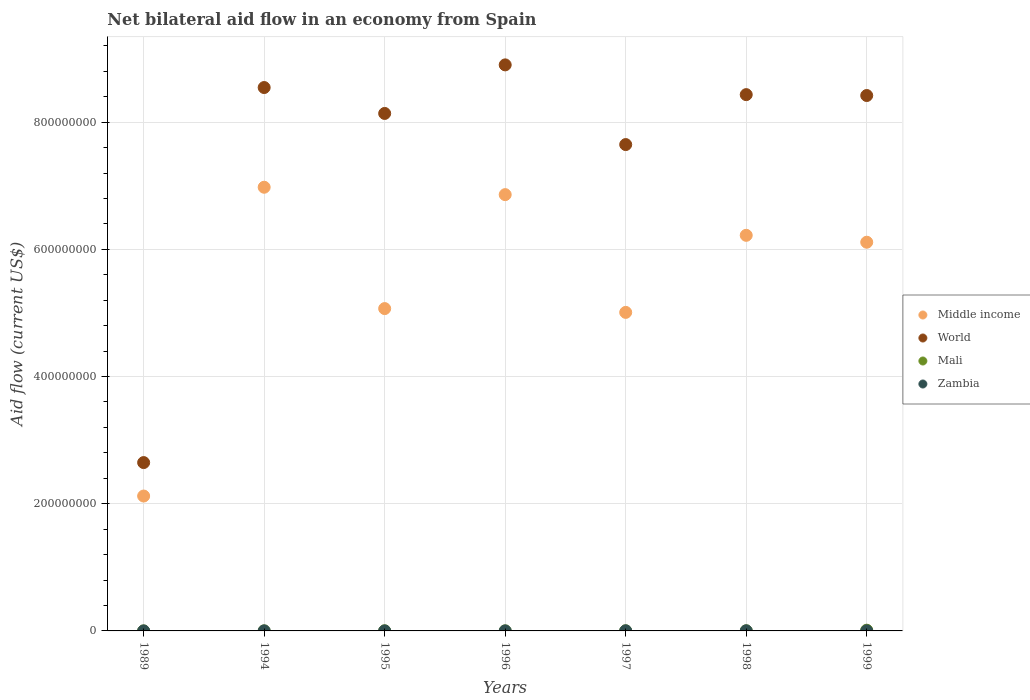How many different coloured dotlines are there?
Provide a short and direct response. 4. Is the number of dotlines equal to the number of legend labels?
Keep it short and to the point. Yes. Across all years, what is the minimum net bilateral aid flow in Zambia?
Give a very brief answer. 10000. What is the total net bilateral aid flow in World in the graph?
Your answer should be very brief. 5.27e+09. What is the difference between the net bilateral aid flow in Zambia in 1998 and that in 1999?
Make the answer very short. 10000. What is the difference between the net bilateral aid flow in Middle income in 1998 and the net bilateral aid flow in World in 1999?
Provide a succinct answer. -2.20e+08. What is the average net bilateral aid flow in Middle income per year?
Ensure brevity in your answer.  5.48e+08. In the year 1999, what is the difference between the net bilateral aid flow in Mali and net bilateral aid flow in Zambia?
Give a very brief answer. 9.90e+05. What is the ratio of the net bilateral aid flow in Middle income in 1997 to that in 1998?
Your answer should be compact. 0.81. Is the net bilateral aid flow in Mali in 1994 less than that in 1997?
Offer a very short reply. Yes. What is the difference between the highest and the second highest net bilateral aid flow in Mali?
Keep it short and to the point. 9.30e+05. What is the difference between the highest and the lowest net bilateral aid flow in Middle income?
Give a very brief answer. 4.86e+08. Does the net bilateral aid flow in World monotonically increase over the years?
Your response must be concise. No. Is the net bilateral aid flow in Middle income strictly less than the net bilateral aid flow in Zambia over the years?
Make the answer very short. No. How many dotlines are there?
Offer a very short reply. 4. Does the graph contain any zero values?
Keep it short and to the point. No. Where does the legend appear in the graph?
Make the answer very short. Center right. How many legend labels are there?
Ensure brevity in your answer.  4. How are the legend labels stacked?
Your answer should be very brief. Vertical. What is the title of the graph?
Provide a succinct answer. Net bilateral aid flow in an economy from Spain. Does "Yemen, Rep." appear as one of the legend labels in the graph?
Ensure brevity in your answer.  No. What is the label or title of the X-axis?
Your answer should be very brief. Years. What is the Aid flow (current US$) of Middle income in 1989?
Offer a very short reply. 2.12e+08. What is the Aid flow (current US$) in World in 1989?
Give a very brief answer. 2.65e+08. What is the Aid flow (current US$) in Zambia in 1989?
Make the answer very short. 10000. What is the Aid flow (current US$) of Middle income in 1994?
Ensure brevity in your answer.  6.98e+08. What is the Aid flow (current US$) in World in 1994?
Provide a short and direct response. 8.54e+08. What is the Aid flow (current US$) of Mali in 1994?
Keep it short and to the point. 8.00e+04. What is the Aid flow (current US$) in Middle income in 1995?
Your answer should be very brief. 5.07e+08. What is the Aid flow (current US$) in World in 1995?
Offer a terse response. 8.14e+08. What is the Aid flow (current US$) in Mali in 1995?
Keep it short and to the point. 1.90e+05. What is the Aid flow (current US$) in Zambia in 1995?
Provide a short and direct response. 2.00e+04. What is the Aid flow (current US$) of Middle income in 1996?
Your answer should be compact. 6.86e+08. What is the Aid flow (current US$) of World in 1996?
Keep it short and to the point. 8.90e+08. What is the Aid flow (current US$) in Zambia in 1996?
Provide a succinct answer. 2.00e+04. What is the Aid flow (current US$) of Middle income in 1997?
Offer a very short reply. 5.01e+08. What is the Aid flow (current US$) in World in 1997?
Offer a terse response. 7.65e+08. What is the Aid flow (current US$) of Mali in 1997?
Offer a very short reply. 1.80e+05. What is the Aid flow (current US$) in Middle income in 1998?
Give a very brief answer. 6.22e+08. What is the Aid flow (current US$) of World in 1998?
Offer a terse response. 8.43e+08. What is the Aid flow (current US$) in Mali in 1998?
Give a very brief answer. 2.10e+05. What is the Aid flow (current US$) in Zambia in 1998?
Keep it short and to the point. 1.60e+05. What is the Aid flow (current US$) of Middle income in 1999?
Your response must be concise. 6.11e+08. What is the Aid flow (current US$) of World in 1999?
Offer a very short reply. 8.42e+08. What is the Aid flow (current US$) in Mali in 1999?
Provide a short and direct response. 1.14e+06. Across all years, what is the maximum Aid flow (current US$) of Middle income?
Your answer should be compact. 6.98e+08. Across all years, what is the maximum Aid flow (current US$) of World?
Provide a succinct answer. 8.90e+08. Across all years, what is the maximum Aid flow (current US$) of Mali?
Your response must be concise. 1.14e+06. Across all years, what is the maximum Aid flow (current US$) of Zambia?
Ensure brevity in your answer.  1.70e+05. Across all years, what is the minimum Aid flow (current US$) of Middle income?
Your answer should be very brief. 2.12e+08. Across all years, what is the minimum Aid flow (current US$) of World?
Offer a terse response. 2.65e+08. Across all years, what is the minimum Aid flow (current US$) in Mali?
Your response must be concise. 10000. What is the total Aid flow (current US$) of Middle income in the graph?
Offer a terse response. 3.84e+09. What is the total Aid flow (current US$) of World in the graph?
Offer a terse response. 5.27e+09. What is the total Aid flow (current US$) of Mali in the graph?
Your answer should be compact. 1.91e+06. What is the total Aid flow (current US$) in Zambia in the graph?
Make the answer very short. 5.90e+05. What is the difference between the Aid flow (current US$) of Middle income in 1989 and that in 1994?
Your answer should be very brief. -4.86e+08. What is the difference between the Aid flow (current US$) of World in 1989 and that in 1994?
Provide a succinct answer. -5.90e+08. What is the difference between the Aid flow (current US$) of Zambia in 1989 and that in 1994?
Ensure brevity in your answer.  -5.00e+04. What is the difference between the Aid flow (current US$) in Middle income in 1989 and that in 1995?
Offer a terse response. -2.95e+08. What is the difference between the Aid flow (current US$) in World in 1989 and that in 1995?
Your answer should be very brief. -5.49e+08. What is the difference between the Aid flow (current US$) in Mali in 1989 and that in 1995?
Your answer should be very brief. -1.80e+05. What is the difference between the Aid flow (current US$) of Middle income in 1989 and that in 1996?
Your answer should be very brief. -4.74e+08. What is the difference between the Aid flow (current US$) in World in 1989 and that in 1996?
Your answer should be compact. -6.25e+08. What is the difference between the Aid flow (current US$) of Mali in 1989 and that in 1996?
Ensure brevity in your answer.  -9.00e+04. What is the difference between the Aid flow (current US$) in Zambia in 1989 and that in 1996?
Provide a succinct answer. -10000. What is the difference between the Aid flow (current US$) in Middle income in 1989 and that in 1997?
Keep it short and to the point. -2.89e+08. What is the difference between the Aid flow (current US$) of World in 1989 and that in 1997?
Offer a very short reply. -5.00e+08. What is the difference between the Aid flow (current US$) in Mali in 1989 and that in 1997?
Your answer should be very brief. -1.70e+05. What is the difference between the Aid flow (current US$) of Middle income in 1989 and that in 1998?
Your answer should be compact. -4.10e+08. What is the difference between the Aid flow (current US$) in World in 1989 and that in 1998?
Give a very brief answer. -5.79e+08. What is the difference between the Aid flow (current US$) of Mali in 1989 and that in 1998?
Provide a short and direct response. -2.00e+05. What is the difference between the Aid flow (current US$) in Zambia in 1989 and that in 1998?
Your response must be concise. -1.50e+05. What is the difference between the Aid flow (current US$) of Middle income in 1989 and that in 1999?
Keep it short and to the point. -3.99e+08. What is the difference between the Aid flow (current US$) in World in 1989 and that in 1999?
Provide a short and direct response. -5.77e+08. What is the difference between the Aid flow (current US$) of Mali in 1989 and that in 1999?
Ensure brevity in your answer.  -1.13e+06. What is the difference between the Aid flow (current US$) of Middle income in 1994 and that in 1995?
Your answer should be very brief. 1.91e+08. What is the difference between the Aid flow (current US$) in World in 1994 and that in 1995?
Ensure brevity in your answer.  4.07e+07. What is the difference between the Aid flow (current US$) in Mali in 1994 and that in 1995?
Your answer should be compact. -1.10e+05. What is the difference between the Aid flow (current US$) in Zambia in 1994 and that in 1995?
Give a very brief answer. 4.00e+04. What is the difference between the Aid flow (current US$) of Middle income in 1994 and that in 1996?
Your response must be concise. 1.16e+07. What is the difference between the Aid flow (current US$) in World in 1994 and that in 1996?
Your answer should be compact. -3.56e+07. What is the difference between the Aid flow (current US$) in Mali in 1994 and that in 1996?
Make the answer very short. -2.00e+04. What is the difference between the Aid flow (current US$) in Zambia in 1994 and that in 1996?
Your answer should be compact. 4.00e+04. What is the difference between the Aid flow (current US$) in Middle income in 1994 and that in 1997?
Ensure brevity in your answer.  1.97e+08. What is the difference between the Aid flow (current US$) in World in 1994 and that in 1997?
Offer a very short reply. 8.97e+07. What is the difference between the Aid flow (current US$) in Middle income in 1994 and that in 1998?
Provide a short and direct response. 7.56e+07. What is the difference between the Aid flow (current US$) of World in 1994 and that in 1998?
Keep it short and to the point. 1.12e+07. What is the difference between the Aid flow (current US$) in Zambia in 1994 and that in 1998?
Provide a succinct answer. -1.00e+05. What is the difference between the Aid flow (current US$) in Middle income in 1994 and that in 1999?
Make the answer very short. 8.65e+07. What is the difference between the Aid flow (current US$) in World in 1994 and that in 1999?
Make the answer very short. 1.26e+07. What is the difference between the Aid flow (current US$) in Mali in 1994 and that in 1999?
Provide a short and direct response. -1.06e+06. What is the difference between the Aid flow (current US$) of Zambia in 1994 and that in 1999?
Offer a terse response. -9.00e+04. What is the difference between the Aid flow (current US$) of Middle income in 1995 and that in 1996?
Keep it short and to the point. -1.79e+08. What is the difference between the Aid flow (current US$) in World in 1995 and that in 1996?
Your answer should be compact. -7.64e+07. What is the difference between the Aid flow (current US$) in Mali in 1995 and that in 1996?
Your answer should be very brief. 9.00e+04. What is the difference between the Aid flow (current US$) of Zambia in 1995 and that in 1996?
Ensure brevity in your answer.  0. What is the difference between the Aid flow (current US$) in Middle income in 1995 and that in 1997?
Ensure brevity in your answer.  5.98e+06. What is the difference between the Aid flow (current US$) in World in 1995 and that in 1997?
Your answer should be compact. 4.89e+07. What is the difference between the Aid flow (current US$) in Mali in 1995 and that in 1997?
Your answer should be compact. 10000. What is the difference between the Aid flow (current US$) of Zambia in 1995 and that in 1997?
Offer a terse response. -1.50e+05. What is the difference between the Aid flow (current US$) of Middle income in 1995 and that in 1998?
Your response must be concise. -1.15e+08. What is the difference between the Aid flow (current US$) of World in 1995 and that in 1998?
Provide a short and direct response. -2.96e+07. What is the difference between the Aid flow (current US$) in Mali in 1995 and that in 1998?
Offer a terse response. -2.00e+04. What is the difference between the Aid flow (current US$) in Middle income in 1995 and that in 1999?
Offer a terse response. -1.04e+08. What is the difference between the Aid flow (current US$) of World in 1995 and that in 1999?
Offer a very short reply. -2.82e+07. What is the difference between the Aid flow (current US$) in Mali in 1995 and that in 1999?
Give a very brief answer. -9.50e+05. What is the difference between the Aid flow (current US$) in Zambia in 1995 and that in 1999?
Provide a succinct answer. -1.30e+05. What is the difference between the Aid flow (current US$) of Middle income in 1996 and that in 1997?
Your answer should be compact. 1.85e+08. What is the difference between the Aid flow (current US$) in World in 1996 and that in 1997?
Make the answer very short. 1.25e+08. What is the difference between the Aid flow (current US$) of Mali in 1996 and that in 1997?
Ensure brevity in your answer.  -8.00e+04. What is the difference between the Aid flow (current US$) in Middle income in 1996 and that in 1998?
Keep it short and to the point. 6.40e+07. What is the difference between the Aid flow (current US$) of World in 1996 and that in 1998?
Your response must be concise. 4.68e+07. What is the difference between the Aid flow (current US$) in Middle income in 1996 and that in 1999?
Provide a short and direct response. 7.48e+07. What is the difference between the Aid flow (current US$) of World in 1996 and that in 1999?
Your answer should be very brief. 4.82e+07. What is the difference between the Aid flow (current US$) in Mali in 1996 and that in 1999?
Ensure brevity in your answer.  -1.04e+06. What is the difference between the Aid flow (current US$) of Middle income in 1997 and that in 1998?
Offer a terse response. -1.21e+08. What is the difference between the Aid flow (current US$) of World in 1997 and that in 1998?
Ensure brevity in your answer.  -7.85e+07. What is the difference between the Aid flow (current US$) of Mali in 1997 and that in 1998?
Offer a terse response. -3.00e+04. What is the difference between the Aid flow (current US$) of Middle income in 1997 and that in 1999?
Provide a succinct answer. -1.10e+08. What is the difference between the Aid flow (current US$) of World in 1997 and that in 1999?
Provide a short and direct response. -7.71e+07. What is the difference between the Aid flow (current US$) of Mali in 1997 and that in 1999?
Give a very brief answer. -9.60e+05. What is the difference between the Aid flow (current US$) of Middle income in 1998 and that in 1999?
Ensure brevity in your answer.  1.09e+07. What is the difference between the Aid flow (current US$) in World in 1998 and that in 1999?
Your answer should be compact. 1.40e+06. What is the difference between the Aid flow (current US$) in Mali in 1998 and that in 1999?
Make the answer very short. -9.30e+05. What is the difference between the Aid flow (current US$) of Middle income in 1989 and the Aid flow (current US$) of World in 1994?
Your response must be concise. -6.42e+08. What is the difference between the Aid flow (current US$) of Middle income in 1989 and the Aid flow (current US$) of Mali in 1994?
Offer a very short reply. 2.12e+08. What is the difference between the Aid flow (current US$) of Middle income in 1989 and the Aid flow (current US$) of Zambia in 1994?
Provide a succinct answer. 2.12e+08. What is the difference between the Aid flow (current US$) of World in 1989 and the Aid flow (current US$) of Mali in 1994?
Your answer should be compact. 2.65e+08. What is the difference between the Aid flow (current US$) of World in 1989 and the Aid flow (current US$) of Zambia in 1994?
Provide a short and direct response. 2.65e+08. What is the difference between the Aid flow (current US$) in Middle income in 1989 and the Aid flow (current US$) in World in 1995?
Offer a very short reply. -6.02e+08. What is the difference between the Aid flow (current US$) in Middle income in 1989 and the Aid flow (current US$) in Mali in 1995?
Offer a terse response. 2.12e+08. What is the difference between the Aid flow (current US$) of Middle income in 1989 and the Aid flow (current US$) of Zambia in 1995?
Your answer should be very brief. 2.12e+08. What is the difference between the Aid flow (current US$) in World in 1989 and the Aid flow (current US$) in Mali in 1995?
Provide a succinct answer. 2.64e+08. What is the difference between the Aid flow (current US$) of World in 1989 and the Aid flow (current US$) of Zambia in 1995?
Keep it short and to the point. 2.65e+08. What is the difference between the Aid flow (current US$) in Middle income in 1989 and the Aid flow (current US$) in World in 1996?
Make the answer very short. -6.78e+08. What is the difference between the Aid flow (current US$) in Middle income in 1989 and the Aid flow (current US$) in Mali in 1996?
Make the answer very short. 2.12e+08. What is the difference between the Aid flow (current US$) of Middle income in 1989 and the Aid flow (current US$) of Zambia in 1996?
Your response must be concise. 2.12e+08. What is the difference between the Aid flow (current US$) of World in 1989 and the Aid flow (current US$) of Mali in 1996?
Your response must be concise. 2.65e+08. What is the difference between the Aid flow (current US$) of World in 1989 and the Aid flow (current US$) of Zambia in 1996?
Your answer should be very brief. 2.65e+08. What is the difference between the Aid flow (current US$) of Mali in 1989 and the Aid flow (current US$) of Zambia in 1996?
Keep it short and to the point. -10000. What is the difference between the Aid flow (current US$) of Middle income in 1989 and the Aid flow (current US$) of World in 1997?
Your answer should be very brief. -5.53e+08. What is the difference between the Aid flow (current US$) in Middle income in 1989 and the Aid flow (current US$) in Mali in 1997?
Provide a succinct answer. 2.12e+08. What is the difference between the Aid flow (current US$) in Middle income in 1989 and the Aid flow (current US$) in Zambia in 1997?
Ensure brevity in your answer.  2.12e+08. What is the difference between the Aid flow (current US$) of World in 1989 and the Aid flow (current US$) of Mali in 1997?
Keep it short and to the point. 2.65e+08. What is the difference between the Aid flow (current US$) in World in 1989 and the Aid flow (current US$) in Zambia in 1997?
Provide a succinct answer. 2.65e+08. What is the difference between the Aid flow (current US$) in Middle income in 1989 and the Aid flow (current US$) in World in 1998?
Your response must be concise. -6.31e+08. What is the difference between the Aid flow (current US$) in Middle income in 1989 and the Aid flow (current US$) in Mali in 1998?
Your answer should be compact. 2.12e+08. What is the difference between the Aid flow (current US$) of Middle income in 1989 and the Aid flow (current US$) of Zambia in 1998?
Make the answer very short. 2.12e+08. What is the difference between the Aid flow (current US$) of World in 1989 and the Aid flow (current US$) of Mali in 1998?
Your response must be concise. 2.64e+08. What is the difference between the Aid flow (current US$) of World in 1989 and the Aid flow (current US$) of Zambia in 1998?
Give a very brief answer. 2.65e+08. What is the difference between the Aid flow (current US$) of Mali in 1989 and the Aid flow (current US$) of Zambia in 1998?
Ensure brevity in your answer.  -1.50e+05. What is the difference between the Aid flow (current US$) of Middle income in 1989 and the Aid flow (current US$) of World in 1999?
Offer a very short reply. -6.30e+08. What is the difference between the Aid flow (current US$) in Middle income in 1989 and the Aid flow (current US$) in Mali in 1999?
Your answer should be very brief. 2.11e+08. What is the difference between the Aid flow (current US$) of Middle income in 1989 and the Aid flow (current US$) of Zambia in 1999?
Provide a succinct answer. 2.12e+08. What is the difference between the Aid flow (current US$) in World in 1989 and the Aid flow (current US$) in Mali in 1999?
Provide a short and direct response. 2.64e+08. What is the difference between the Aid flow (current US$) of World in 1989 and the Aid flow (current US$) of Zambia in 1999?
Keep it short and to the point. 2.65e+08. What is the difference between the Aid flow (current US$) of Mali in 1989 and the Aid flow (current US$) of Zambia in 1999?
Provide a short and direct response. -1.40e+05. What is the difference between the Aid flow (current US$) in Middle income in 1994 and the Aid flow (current US$) in World in 1995?
Your response must be concise. -1.16e+08. What is the difference between the Aid flow (current US$) in Middle income in 1994 and the Aid flow (current US$) in Mali in 1995?
Keep it short and to the point. 6.97e+08. What is the difference between the Aid flow (current US$) of Middle income in 1994 and the Aid flow (current US$) of Zambia in 1995?
Keep it short and to the point. 6.98e+08. What is the difference between the Aid flow (current US$) in World in 1994 and the Aid flow (current US$) in Mali in 1995?
Your answer should be very brief. 8.54e+08. What is the difference between the Aid flow (current US$) of World in 1994 and the Aid flow (current US$) of Zambia in 1995?
Make the answer very short. 8.54e+08. What is the difference between the Aid flow (current US$) of Middle income in 1994 and the Aid flow (current US$) of World in 1996?
Give a very brief answer. -1.92e+08. What is the difference between the Aid flow (current US$) in Middle income in 1994 and the Aid flow (current US$) in Mali in 1996?
Make the answer very short. 6.98e+08. What is the difference between the Aid flow (current US$) of Middle income in 1994 and the Aid flow (current US$) of Zambia in 1996?
Offer a terse response. 6.98e+08. What is the difference between the Aid flow (current US$) in World in 1994 and the Aid flow (current US$) in Mali in 1996?
Your answer should be very brief. 8.54e+08. What is the difference between the Aid flow (current US$) in World in 1994 and the Aid flow (current US$) in Zambia in 1996?
Offer a terse response. 8.54e+08. What is the difference between the Aid flow (current US$) of Middle income in 1994 and the Aid flow (current US$) of World in 1997?
Offer a terse response. -6.71e+07. What is the difference between the Aid flow (current US$) in Middle income in 1994 and the Aid flow (current US$) in Mali in 1997?
Give a very brief answer. 6.97e+08. What is the difference between the Aid flow (current US$) in Middle income in 1994 and the Aid flow (current US$) in Zambia in 1997?
Make the answer very short. 6.97e+08. What is the difference between the Aid flow (current US$) in World in 1994 and the Aid flow (current US$) in Mali in 1997?
Keep it short and to the point. 8.54e+08. What is the difference between the Aid flow (current US$) in World in 1994 and the Aid flow (current US$) in Zambia in 1997?
Keep it short and to the point. 8.54e+08. What is the difference between the Aid flow (current US$) in Mali in 1994 and the Aid flow (current US$) in Zambia in 1997?
Give a very brief answer. -9.00e+04. What is the difference between the Aid flow (current US$) in Middle income in 1994 and the Aid flow (current US$) in World in 1998?
Give a very brief answer. -1.46e+08. What is the difference between the Aid flow (current US$) of Middle income in 1994 and the Aid flow (current US$) of Mali in 1998?
Your answer should be compact. 6.97e+08. What is the difference between the Aid flow (current US$) of Middle income in 1994 and the Aid flow (current US$) of Zambia in 1998?
Your answer should be compact. 6.97e+08. What is the difference between the Aid flow (current US$) of World in 1994 and the Aid flow (current US$) of Mali in 1998?
Your answer should be very brief. 8.54e+08. What is the difference between the Aid flow (current US$) of World in 1994 and the Aid flow (current US$) of Zambia in 1998?
Your answer should be compact. 8.54e+08. What is the difference between the Aid flow (current US$) in Middle income in 1994 and the Aid flow (current US$) in World in 1999?
Provide a short and direct response. -1.44e+08. What is the difference between the Aid flow (current US$) of Middle income in 1994 and the Aid flow (current US$) of Mali in 1999?
Keep it short and to the point. 6.96e+08. What is the difference between the Aid flow (current US$) in Middle income in 1994 and the Aid flow (current US$) in Zambia in 1999?
Your response must be concise. 6.97e+08. What is the difference between the Aid flow (current US$) of World in 1994 and the Aid flow (current US$) of Mali in 1999?
Offer a very short reply. 8.53e+08. What is the difference between the Aid flow (current US$) in World in 1994 and the Aid flow (current US$) in Zambia in 1999?
Offer a very short reply. 8.54e+08. What is the difference between the Aid flow (current US$) of Middle income in 1995 and the Aid flow (current US$) of World in 1996?
Make the answer very short. -3.83e+08. What is the difference between the Aid flow (current US$) in Middle income in 1995 and the Aid flow (current US$) in Mali in 1996?
Offer a very short reply. 5.07e+08. What is the difference between the Aid flow (current US$) of Middle income in 1995 and the Aid flow (current US$) of Zambia in 1996?
Your response must be concise. 5.07e+08. What is the difference between the Aid flow (current US$) of World in 1995 and the Aid flow (current US$) of Mali in 1996?
Provide a succinct answer. 8.14e+08. What is the difference between the Aid flow (current US$) in World in 1995 and the Aid flow (current US$) in Zambia in 1996?
Your answer should be compact. 8.14e+08. What is the difference between the Aid flow (current US$) in Middle income in 1995 and the Aid flow (current US$) in World in 1997?
Make the answer very short. -2.58e+08. What is the difference between the Aid flow (current US$) of Middle income in 1995 and the Aid flow (current US$) of Mali in 1997?
Offer a terse response. 5.07e+08. What is the difference between the Aid flow (current US$) in Middle income in 1995 and the Aid flow (current US$) in Zambia in 1997?
Give a very brief answer. 5.07e+08. What is the difference between the Aid flow (current US$) in World in 1995 and the Aid flow (current US$) in Mali in 1997?
Offer a very short reply. 8.13e+08. What is the difference between the Aid flow (current US$) in World in 1995 and the Aid flow (current US$) in Zambia in 1997?
Provide a short and direct response. 8.13e+08. What is the difference between the Aid flow (current US$) of Mali in 1995 and the Aid flow (current US$) of Zambia in 1997?
Your answer should be compact. 2.00e+04. What is the difference between the Aid flow (current US$) in Middle income in 1995 and the Aid flow (current US$) in World in 1998?
Offer a very short reply. -3.36e+08. What is the difference between the Aid flow (current US$) in Middle income in 1995 and the Aid flow (current US$) in Mali in 1998?
Your answer should be compact. 5.07e+08. What is the difference between the Aid flow (current US$) in Middle income in 1995 and the Aid flow (current US$) in Zambia in 1998?
Provide a short and direct response. 5.07e+08. What is the difference between the Aid flow (current US$) in World in 1995 and the Aid flow (current US$) in Mali in 1998?
Provide a succinct answer. 8.13e+08. What is the difference between the Aid flow (current US$) in World in 1995 and the Aid flow (current US$) in Zambia in 1998?
Ensure brevity in your answer.  8.13e+08. What is the difference between the Aid flow (current US$) of Mali in 1995 and the Aid flow (current US$) of Zambia in 1998?
Keep it short and to the point. 3.00e+04. What is the difference between the Aid flow (current US$) in Middle income in 1995 and the Aid flow (current US$) in World in 1999?
Your answer should be compact. -3.35e+08. What is the difference between the Aid flow (current US$) of Middle income in 1995 and the Aid flow (current US$) of Mali in 1999?
Your response must be concise. 5.06e+08. What is the difference between the Aid flow (current US$) of Middle income in 1995 and the Aid flow (current US$) of Zambia in 1999?
Make the answer very short. 5.07e+08. What is the difference between the Aid flow (current US$) of World in 1995 and the Aid flow (current US$) of Mali in 1999?
Keep it short and to the point. 8.12e+08. What is the difference between the Aid flow (current US$) of World in 1995 and the Aid flow (current US$) of Zambia in 1999?
Your answer should be very brief. 8.13e+08. What is the difference between the Aid flow (current US$) in Mali in 1995 and the Aid flow (current US$) in Zambia in 1999?
Your answer should be compact. 4.00e+04. What is the difference between the Aid flow (current US$) of Middle income in 1996 and the Aid flow (current US$) of World in 1997?
Give a very brief answer. -7.87e+07. What is the difference between the Aid flow (current US$) in Middle income in 1996 and the Aid flow (current US$) in Mali in 1997?
Offer a very short reply. 6.86e+08. What is the difference between the Aid flow (current US$) of Middle income in 1996 and the Aid flow (current US$) of Zambia in 1997?
Your answer should be very brief. 6.86e+08. What is the difference between the Aid flow (current US$) of World in 1996 and the Aid flow (current US$) of Mali in 1997?
Make the answer very short. 8.90e+08. What is the difference between the Aid flow (current US$) of World in 1996 and the Aid flow (current US$) of Zambia in 1997?
Provide a short and direct response. 8.90e+08. What is the difference between the Aid flow (current US$) in Mali in 1996 and the Aid flow (current US$) in Zambia in 1997?
Provide a short and direct response. -7.00e+04. What is the difference between the Aid flow (current US$) of Middle income in 1996 and the Aid flow (current US$) of World in 1998?
Offer a terse response. -1.57e+08. What is the difference between the Aid flow (current US$) in Middle income in 1996 and the Aid flow (current US$) in Mali in 1998?
Make the answer very short. 6.86e+08. What is the difference between the Aid flow (current US$) in Middle income in 1996 and the Aid flow (current US$) in Zambia in 1998?
Make the answer very short. 6.86e+08. What is the difference between the Aid flow (current US$) of World in 1996 and the Aid flow (current US$) of Mali in 1998?
Offer a terse response. 8.90e+08. What is the difference between the Aid flow (current US$) of World in 1996 and the Aid flow (current US$) of Zambia in 1998?
Your answer should be compact. 8.90e+08. What is the difference between the Aid flow (current US$) of Middle income in 1996 and the Aid flow (current US$) of World in 1999?
Ensure brevity in your answer.  -1.56e+08. What is the difference between the Aid flow (current US$) of Middle income in 1996 and the Aid flow (current US$) of Mali in 1999?
Ensure brevity in your answer.  6.85e+08. What is the difference between the Aid flow (current US$) in Middle income in 1996 and the Aid flow (current US$) in Zambia in 1999?
Keep it short and to the point. 6.86e+08. What is the difference between the Aid flow (current US$) of World in 1996 and the Aid flow (current US$) of Mali in 1999?
Offer a very short reply. 8.89e+08. What is the difference between the Aid flow (current US$) in World in 1996 and the Aid flow (current US$) in Zambia in 1999?
Provide a short and direct response. 8.90e+08. What is the difference between the Aid flow (current US$) of Mali in 1996 and the Aid flow (current US$) of Zambia in 1999?
Your answer should be very brief. -5.00e+04. What is the difference between the Aid flow (current US$) of Middle income in 1997 and the Aid flow (current US$) of World in 1998?
Offer a very short reply. -3.42e+08. What is the difference between the Aid flow (current US$) of Middle income in 1997 and the Aid flow (current US$) of Mali in 1998?
Provide a succinct answer. 5.01e+08. What is the difference between the Aid flow (current US$) of Middle income in 1997 and the Aid flow (current US$) of Zambia in 1998?
Offer a very short reply. 5.01e+08. What is the difference between the Aid flow (current US$) of World in 1997 and the Aid flow (current US$) of Mali in 1998?
Offer a very short reply. 7.64e+08. What is the difference between the Aid flow (current US$) in World in 1997 and the Aid flow (current US$) in Zambia in 1998?
Provide a succinct answer. 7.65e+08. What is the difference between the Aid flow (current US$) in Middle income in 1997 and the Aid flow (current US$) in World in 1999?
Give a very brief answer. -3.41e+08. What is the difference between the Aid flow (current US$) of Middle income in 1997 and the Aid flow (current US$) of Mali in 1999?
Give a very brief answer. 5.00e+08. What is the difference between the Aid flow (current US$) in Middle income in 1997 and the Aid flow (current US$) in Zambia in 1999?
Provide a succinct answer. 5.01e+08. What is the difference between the Aid flow (current US$) of World in 1997 and the Aid flow (current US$) of Mali in 1999?
Make the answer very short. 7.64e+08. What is the difference between the Aid flow (current US$) in World in 1997 and the Aid flow (current US$) in Zambia in 1999?
Make the answer very short. 7.65e+08. What is the difference between the Aid flow (current US$) of Middle income in 1998 and the Aid flow (current US$) of World in 1999?
Your answer should be compact. -2.20e+08. What is the difference between the Aid flow (current US$) in Middle income in 1998 and the Aid flow (current US$) in Mali in 1999?
Offer a very short reply. 6.21e+08. What is the difference between the Aid flow (current US$) in Middle income in 1998 and the Aid flow (current US$) in Zambia in 1999?
Your answer should be very brief. 6.22e+08. What is the difference between the Aid flow (current US$) in World in 1998 and the Aid flow (current US$) in Mali in 1999?
Provide a succinct answer. 8.42e+08. What is the difference between the Aid flow (current US$) in World in 1998 and the Aid flow (current US$) in Zambia in 1999?
Ensure brevity in your answer.  8.43e+08. What is the average Aid flow (current US$) of Middle income per year?
Offer a very short reply. 5.48e+08. What is the average Aid flow (current US$) in World per year?
Provide a short and direct response. 7.53e+08. What is the average Aid flow (current US$) of Mali per year?
Make the answer very short. 2.73e+05. What is the average Aid flow (current US$) of Zambia per year?
Your response must be concise. 8.43e+04. In the year 1989, what is the difference between the Aid flow (current US$) of Middle income and Aid flow (current US$) of World?
Make the answer very short. -5.26e+07. In the year 1989, what is the difference between the Aid flow (current US$) in Middle income and Aid flow (current US$) in Mali?
Your answer should be compact. 2.12e+08. In the year 1989, what is the difference between the Aid flow (current US$) in Middle income and Aid flow (current US$) in Zambia?
Give a very brief answer. 2.12e+08. In the year 1989, what is the difference between the Aid flow (current US$) in World and Aid flow (current US$) in Mali?
Your response must be concise. 2.65e+08. In the year 1989, what is the difference between the Aid flow (current US$) in World and Aid flow (current US$) in Zambia?
Give a very brief answer. 2.65e+08. In the year 1994, what is the difference between the Aid flow (current US$) in Middle income and Aid flow (current US$) in World?
Give a very brief answer. -1.57e+08. In the year 1994, what is the difference between the Aid flow (current US$) in Middle income and Aid flow (current US$) in Mali?
Keep it short and to the point. 6.98e+08. In the year 1994, what is the difference between the Aid flow (current US$) in Middle income and Aid flow (current US$) in Zambia?
Make the answer very short. 6.98e+08. In the year 1994, what is the difference between the Aid flow (current US$) in World and Aid flow (current US$) in Mali?
Give a very brief answer. 8.54e+08. In the year 1994, what is the difference between the Aid flow (current US$) in World and Aid flow (current US$) in Zambia?
Your answer should be compact. 8.54e+08. In the year 1994, what is the difference between the Aid flow (current US$) in Mali and Aid flow (current US$) in Zambia?
Ensure brevity in your answer.  2.00e+04. In the year 1995, what is the difference between the Aid flow (current US$) of Middle income and Aid flow (current US$) of World?
Provide a short and direct response. -3.07e+08. In the year 1995, what is the difference between the Aid flow (current US$) in Middle income and Aid flow (current US$) in Mali?
Provide a succinct answer. 5.07e+08. In the year 1995, what is the difference between the Aid flow (current US$) of Middle income and Aid flow (current US$) of Zambia?
Provide a short and direct response. 5.07e+08. In the year 1995, what is the difference between the Aid flow (current US$) in World and Aid flow (current US$) in Mali?
Your answer should be very brief. 8.13e+08. In the year 1995, what is the difference between the Aid flow (current US$) in World and Aid flow (current US$) in Zambia?
Make the answer very short. 8.14e+08. In the year 1995, what is the difference between the Aid flow (current US$) in Mali and Aid flow (current US$) in Zambia?
Offer a terse response. 1.70e+05. In the year 1996, what is the difference between the Aid flow (current US$) in Middle income and Aid flow (current US$) in World?
Ensure brevity in your answer.  -2.04e+08. In the year 1996, what is the difference between the Aid flow (current US$) of Middle income and Aid flow (current US$) of Mali?
Keep it short and to the point. 6.86e+08. In the year 1996, what is the difference between the Aid flow (current US$) in Middle income and Aid flow (current US$) in Zambia?
Your answer should be very brief. 6.86e+08. In the year 1996, what is the difference between the Aid flow (current US$) in World and Aid flow (current US$) in Mali?
Keep it short and to the point. 8.90e+08. In the year 1996, what is the difference between the Aid flow (current US$) of World and Aid flow (current US$) of Zambia?
Your response must be concise. 8.90e+08. In the year 1997, what is the difference between the Aid flow (current US$) in Middle income and Aid flow (current US$) in World?
Keep it short and to the point. -2.64e+08. In the year 1997, what is the difference between the Aid flow (current US$) in Middle income and Aid flow (current US$) in Mali?
Offer a terse response. 5.01e+08. In the year 1997, what is the difference between the Aid flow (current US$) of Middle income and Aid flow (current US$) of Zambia?
Offer a terse response. 5.01e+08. In the year 1997, what is the difference between the Aid flow (current US$) of World and Aid flow (current US$) of Mali?
Offer a terse response. 7.65e+08. In the year 1997, what is the difference between the Aid flow (current US$) of World and Aid flow (current US$) of Zambia?
Your response must be concise. 7.65e+08. In the year 1998, what is the difference between the Aid flow (current US$) in Middle income and Aid flow (current US$) in World?
Offer a very short reply. -2.21e+08. In the year 1998, what is the difference between the Aid flow (current US$) in Middle income and Aid flow (current US$) in Mali?
Keep it short and to the point. 6.22e+08. In the year 1998, what is the difference between the Aid flow (current US$) of Middle income and Aid flow (current US$) of Zambia?
Give a very brief answer. 6.22e+08. In the year 1998, what is the difference between the Aid flow (current US$) in World and Aid flow (current US$) in Mali?
Provide a short and direct response. 8.43e+08. In the year 1998, what is the difference between the Aid flow (current US$) of World and Aid flow (current US$) of Zambia?
Offer a terse response. 8.43e+08. In the year 1999, what is the difference between the Aid flow (current US$) of Middle income and Aid flow (current US$) of World?
Provide a short and direct response. -2.31e+08. In the year 1999, what is the difference between the Aid flow (current US$) of Middle income and Aid flow (current US$) of Mali?
Provide a short and direct response. 6.10e+08. In the year 1999, what is the difference between the Aid flow (current US$) of Middle income and Aid flow (current US$) of Zambia?
Offer a terse response. 6.11e+08. In the year 1999, what is the difference between the Aid flow (current US$) of World and Aid flow (current US$) of Mali?
Ensure brevity in your answer.  8.41e+08. In the year 1999, what is the difference between the Aid flow (current US$) of World and Aid flow (current US$) of Zambia?
Your answer should be compact. 8.42e+08. In the year 1999, what is the difference between the Aid flow (current US$) of Mali and Aid flow (current US$) of Zambia?
Ensure brevity in your answer.  9.90e+05. What is the ratio of the Aid flow (current US$) of Middle income in 1989 to that in 1994?
Offer a terse response. 0.3. What is the ratio of the Aid flow (current US$) of World in 1989 to that in 1994?
Offer a very short reply. 0.31. What is the ratio of the Aid flow (current US$) in Middle income in 1989 to that in 1995?
Make the answer very short. 0.42. What is the ratio of the Aid flow (current US$) of World in 1989 to that in 1995?
Your answer should be compact. 0.33. What is the ratio of the Aid flow (current US$) in Mali in 1989 to that in 1995?
Your response must be concise. 0.05. What is the ratio of the Aid flow (current US$) in Middle income in 1989 to that in 1996?
Give a very brief answer. 0.31. What is the ratio of the Aid flow (current US$) in World in 1989 to that in 1996?
Your answer should be very brief. 0.3. What is the ratio of the Aid flow (current US$) in Zambia in 1989 to that in 1996?
Ensure brevity in your answer.  0.5. What is the ratio of the Aid flow (current US$) of Middle income in 1989 to that in 1997?
Offer a terse response. 0.42. What is the ratio of the Aid flow (current US$) of World in 1989 to that in 1997?
Provide a short and direct response. 0.35. What is the ratio of the Aid flow (current US$) in Mali in 1989 to that in 1997?
Keep it short and to the point. 0.06. What is the ratio of the Aid flow (current US$) of Zambia in 1989 to that in 1997?
Offer a very short reply. 0.06. What is the ratio of the Aid flow (current US$) of Middle income in 1989 to that in 1998?
Your answer should be compact. 0.34. What is the ratio of the Aid flow (current US$) in World in 1989 to that in 1998?
Keep it short and to the point. 0.31. What is the ratio of the Aid flow (current US$) of Mali in 1989 to that in 1998?
Keep it short and to the point. 0.05. What is the ratio of the Aid flow (current US$) in Zambia in 1989 to that in 1998?
Give a very brief answer. 0.06. What is the ratio of the Aid flow (current US$) of Middle income in 1989 to that in 1999?
Provide a succinct answer. 0.35. What is the ratio of the Aid flow (current US$) in World in 1989 to that in 1999?
Make the answer very short. 0.31. What is the ratio of the Aid flow (current US$) of Mali in 1989 to that in 1999?
Give a very brief answer. 0.01. What is the ratio of the Aid flow (current US$) of Zambia in 1989 to that in 1999?
Offer a very short reply. 0.07. What is the ratio of the Aid flow (current US$) in Middle income in 1994 to that in 1995?
Your answer should be very brief. 1.38. What is the ratio of the Aid flow (current US$) in World in 1994 to that in 1995?
Give a very brief answer. 1.05. What is the ratio of the Aid flow (current US$) in Mali in 1994 to that in 1995?
Provide a succinct answer. 0.42. What is the ratio of the Aid flow (current US$) of Middle income in 1994 to that in 1996?
Make the answer very short. 1.02. What is the ratio of the Aid flow (current US$) in Mali in 1994 to that in 1996?
Offer a very short reply. 0.8. What is the ratio of the Aid flow (current US$) in Middle income in 1994 to that in 1997?
Offer a very short reply. 1.39. What is the ratio of the Aid flow (current US$) in World in 1994 to that in 1997?
Your answer should be compact. 1.12. What is the ratio of the Aid flow (current US$) of Mali in 1994 to that in 1997?
Provide a short and direct response. 0.44. What is the ratio of the Aid flow (current US$) in Zambia in 1994 to that in 1997?
Give a very brief answer. 0.35. What is the ratio of the Aid flow (current US$) in Middle income in 1994 to that in 1998?
Your response must be concise. 1.12. What is the ratio of the Aid flow (current US$) in World in 1994 to that in 1998?
Keep it short and to the point. 1.01. What is the ratio of the Aid flow (current US$) in Mali in 1994 to that in 1998?
Make the answer very short. 0.38. What is the ratio of the Aid flow (current US$) of Zambia in 1994 to that in 1998?
Make the answer very short. 0.38. What is the ratio of the Aid flow (current US$) in Middle income in 1994 to that in 1999?
Give a very brief answer. 1.14. What is the ratio of the Aid flow (current US$) of World in 1994 to that in 1999?
Offer a terse response. 1.01. What is the ratio of the Aid flow (current US$) in Mali in 1994 to that in 1999?
Offer a very short reply. 0.07. What is the ratio of the Aid flow (current US$) in Zambia in 1994 to that in 1999?
Your answer should be very brief. 0.4. What is the ratio of the Aid flow (current US$) of Middle income in 1995 to that in 1996?
Keep it short and to the point. 0.74. What is the ratio of the Aid flow (current US$) of World in 1995 to that in 1996?
Make the answer very short. 0.91. What is the ratio of the Aid flow (current US$) in Mali in 1995 to that in 1996?
Give a very brief answer. 1.9. What is the ratio of the Aid flow (current US$) in Zambia in 1995 to that in 1996?
Make the answer very short. 1. What is the ratio of the Aid flow (current US$) of Middle income in 1995 to that in 1997?
Your answer should be very brief. 1.01. What is the ratio of the Aid flow (current US$) in World in 1995 to that in 1997?
Provide a short and direct response. 1.06. What is the ratio of the Aid flow (current US$) of Mali in 1995 to that in 1997?
Your answer should be compact. 1.06. What is the ratio of the Aid flow (current US$) in Zambia in 1995 to that in 1997?
Offer a very short reply. 0.12. What is the ratio of the Aid flow (current US$) of Middle income in 1995 to that in 1998?
Provide a succinct answer. 0.81. What is the ratio of the Aid flow (current US$) in World in 1995 to that in 1998?
Your answer should be very brief. 0.96. What is the ratio of the Aid flow (current US$) of Mali in 1995 to that in 1998?
Your answer should be very brief. 0.9. What is the ratio of the Aid flow (current US$) in Middle income in 1995 to that in 1999?
Ensure brevity in your answer.  0.83. What is the ratio of the Aid flow (current US$) of World in 1995 to that in 1999?
Your answer should be very brief. 0.97. What is the ratio of the Aid flow (current US$) in Mali in 1995 to that in 1999?
Provide a short and direct response. 0.17. What is the ratio of the Aid flow (current US$) of Zambia in 1995 to that in 1999?
Your response must be concise. 0.13. What is the ratio of the Aid flow (current US$) of Middle income in 1996 to that in 1997?
Provide a succinct answer. 1.37. What is the ratio of the Aid flow (current US$) of World in 1996 to that in 1997?
Ensure brevity in your answer.  1.16. What is the ratio of the Aid flow (current US$) in Mali in 1996 to that in 1997?
Your answer should be compact. 0.56. What is the ratio of the Aid flow (current US$) of Zambia in 1996 to that in 1997?
Offer a terse response. 0.12. What is the ratio of the Aid flow (current US$) in Middle income in 1996 to that in 1998?
Offer a very short reply. 1.1. What is the ratio of the Aid flow (current US$) of World in 1996 to that in 1998?
Offer a terse response. 1.06. What is the ratio of the Aid flow (current US$) of Mali in 1996 to that in 1998?
Your response must be concise. 0.48. What is the ratio of the Aid flow (current US$) in Middle income in 1996 to that in 1999?
Provide a short and direct response. 1.12. What is the ratio of the Aid flow (current US$) in World in 1996 to that in 1999?
Your response must be concise. 1.06. What is the ratio of the Aid flow (current US$) in Mali in 1996 to that in 1999?
Give a very brief answer. 0.09. What is the ratio of the Aid flow (current US$) in Zambia in 1996 to that in 1999?
Provide a succinct answer. 0.13. What is the ratio of the Aid flow (current US$) of Middle income in 1997 to that in 1998?
Provide a short and direct response. 0.81. What is the ratio of the Aid flow (current US$) of World in 1997 to that in 1998?
Offer a terse response. 0.91. What is the ratio of the Aid flow (current US$) of Mali in 1997 to that in 1998?
Offer a very short reply. 0.86. What is the ratio of the Aid flow (current US$) of Middle income in 1997 to that in 1999?
Ensure brevity in your answer.  0.82. What is the ratio of the Aid flow (current US$) of World in 1997 to that in 1999?
Offer a terse response. 0.91. What is the ratio of the Aid flow (current US$) in Mali in 1997 to that in 1999?
Provide a succinct answer. 0.16. What is the ratio of the Aid flow (current US$) in Zambia in 1997 to that in 1999?
Make the answer very short. 1.13. What is the ratio of the Aid flow (current US$) in Middle income in 1998 to that in 1999?
Offer a very short reply. 1.02. What is the ratio of the Aid flow (current US$) in Mali in 1998 to that in 1999?
Offer a terse response. 0.18. What is the ratio of the Aid flow (current US$) of Zambia in 1998 to that in 1999?
Your answer should be compact. 1.07. What is the difference between the highest and the second highest Aid flow (current US$) in Middle income?
Keep it short and to the point. 1.16e+07. What is the difference between the highest and the second highest Aid flow (current US$) of World?
Your response must be concise. 3.56e+07. What is the difference between the highest and the second highest Aid flow (current US$) in Mali?
Your answer should be very brief. 9.30e+05. What is the difference between the highest and the lowest Aid flow (current US$) in Middle income?
Provide a succinct answer. 4.86e+08. What is the difference between the highest and the lowest Aid flow (current US$) of World?
Give a very brief answer. 6.25e+08. What is the difference between the highest and the lowest Aid flow (current US$) of Mali?
Give a very brief answer. 1.13e+06. What is the difference between the highest and the lowest Aid flow (current US$) in Zambia?
Provide a succinct answer. 1.60e+05. 